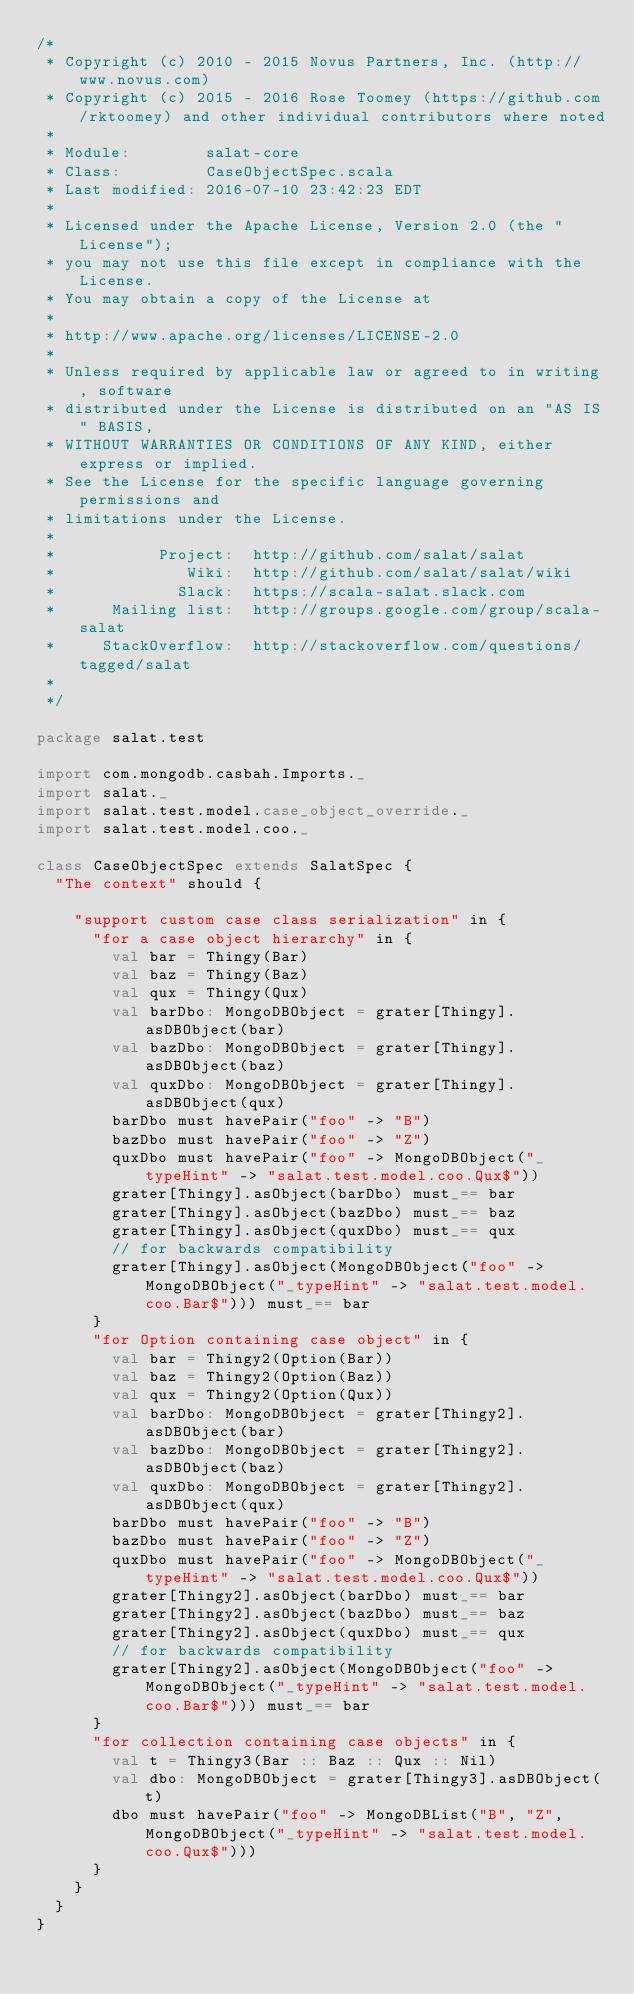<code> <loc_0><loc_0><loc_500><loc_500><_Scala_>/*
 * Copyright (c) 2010 - 2015 Novus Partners, Inc. (http://www.novus.com)
 * Copyright (c) 2015 - 2016 Rose Toomey (https://github.com/rktoomey) and other individual contributors where noted
 *
 * Module:        salat-core
 * Class:         CaseObjectSpec.scala
 * Last modified: 2016-07-10 23:42:23 EDT
 *
 * Licensed under the Apache License, Version 2.0 (the "License");
 * you may not use this file except in compliance with the License.
 * You may obtain a copy of the License at
 *
 * http://www.apache.org/licenses/LICENSE-2.0
 *
 * Unless required by applicable law or agreed to in writing, software
 * distributed under the License is distributed on an "AS IS" BASIS,
 * WITHOUT WARRANTIES OR CONDITIONS OF ANY KIND, either express or implied.
 * See the License for the specific language governing permissions and
 * limitations under the License.
 *
 *           Project:  http://github.com/salat/salat
 *              Wiki:  http://github.com/salat/salat/wiki
 *             Slack:  https://scala-salat.slack.com
 *      Mailing list:  http://groups.google.com/group/scala-salat
 *     StackOverflow:  http://stackoverflow.com/questions/tagged/salat
 *
 */

package salat.test

import com.mongodb.casbah.Imports._
import salat._
import salat.test.model.case_object_override._
import salat.test.model.coo._

class CaseObjectSpec extends SalatSpec {
  "The context" should {

    "support custom case class serialization" in {
      "for a case object hierarchy" in {
        val bar = Thingy(Bar)
        val baz = Thingy(Baz)
        val qux = Thingy(Qux)
        val barDbo: MongoDBObject = grater[Thingy].asDBObject(bar)
        val bazDbo: MongoDBObject = grater[Thingy].asDBObject(baz)
        val quxDbo: MongoDBObject = grater[Thingy].asDBObject(qux)
        barDbo must havePair("foo" -> "B")
        bazDbo must havePair("foo" -> "Z")
        quxDbo must havePair("foo" -> MongoDBObject("_typeHint" -> "salat.test.model.coo.Qux$"))
        grater[Thingy].asObject(barDbo) must_== bar
        grater[Thingy].asObject(bazDbo) must_== baz
        grater[Thingy].asObject(quxDbo) must_== qux
        // for backwards compatibility
        grater[Thingy].asObject(MongoDBObject("foo" -> MongoDBObject("_typeHint" -> "salat.test.model.coo.Bar$"))) must_== bar
      }
      "for Option containing case object" in {
        val bar = Thingy2(Option(Bar))
        val baz = Thingy2(Option(Baz))
        val qux = Thingy2(Option(Qux))
        val barDbo: MongoDBObject = grater[Thingy2].asDBObject(bar)
        val bazDbo: MongoDBObject = grater[Thingy2].asDBObject(baz)
        val quxDbo: MongoDBObject = grater[Thingy2].asDBObject(qux)
        barDbo must havePair("foo" -> "B")
        bazDbo must havePair("foo" -> "Z")
        quxDbo must havePair("foo" -> MongoDBObject("_typeHint" -> "salat.test.model.coo.Qux$"))
        grater[Thingy2].asObject(barDbo) must_== bar
        grater[Thingy2].asObject(bazDbo) must_== baz
        grater[Thingy2].asObject(quxDbo) must_== qux
        // for backwards compatibility
        grater[Thingy2].asObject(MongoDBObject("foo" -> MongoDBObject("_typeHint" -> "salat.test.model.coo.Bar$"))) must_== bar
      }
      "for collection containing case objects" in {
        val t = Thingy3(Bar :: Baz :: Qux :: Nil)
        val dbo: MongoDBObject = grater[Thingy3].asDBObject(t)
        dbo must havePair("foo" -> MongoDBList("B", "Z", MongoDBObject("_typeHint" -> "salat.test.model.coo.Qux$")))
      }
    }
  }
}
</code> 